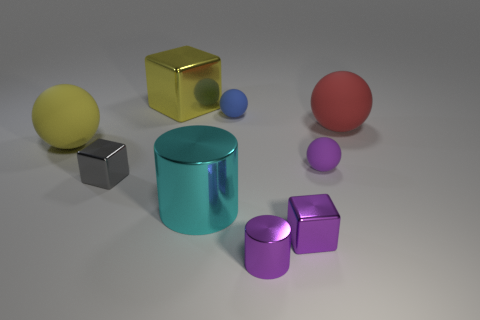There is a big thing that is the same color as the big cube; what is its shape?
Offer a very short reply. Sphere. Is the color of the metallic object behind the red ball the same as the large sphere that is to the left of the big metallic cylinder?
Offer a terse response. Yes. What is the size of the sphere that is the same color as the large metal block?
Provide a short and direct response. Large. Is there a small purple thing that has the same material as the large cube?
Your response must be concise. Yes. The small metallic cylinder has what color?
Give a very brief answer. Purple. There is a shiny block that is behind the ball to the left of the cube behind the tiny purple ball; what is its size?
Give a very brief answer. Large. What number of other things are the same shape as the big cyan thing?
Keep it short and to the point. 1. What color is the metallic object that is behind the purple cylinder and in front of the cyan cylinder?
Offer a very short reply. Purple. Is there any other thing that is the same size as the red thing?
Your response must be concise. Yes. Does the large matte object on the right side of the tiny purple shiny block have the same color as the big metallic cube?
Offer a very short reply. No. 